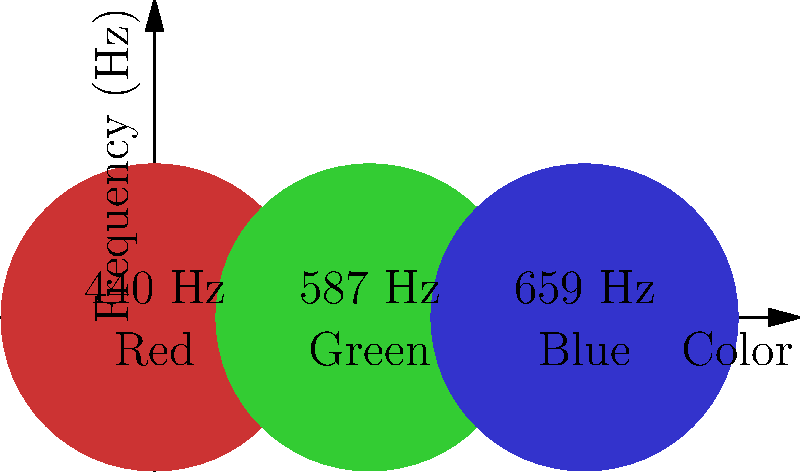Based on the color-frequency mapping shown in the image, which audio frequency would best complement a predominantly blue evening gown in your upcoming runway show? To determine the best audio frequency for a predominantly blue evening gown, we need to follow these steps:

1. Analyze the color-frequency mapping provided in the image:
   - Red is associated with 440 Hz
   - Green is associated with 587 Hz
   - Blue is associated with 659 Hz

2. Identify the color of the evening gown:
   - The question states it's predominantly blue

3. Match the color to its corresponding frequency:
   - Blue corresponds to 659 Hz

4. Consider the context:
   - As a fashion designer, you want to create a cohesive sensory experience
   - Matching the visual color with its corresponding audio frequency can create a harmonious effect

Therefore, to best complement a predominantly blue evening gown, you should choose the audio frequency of 659 Hz for your electronic music track.
Answer: 659 Hz 